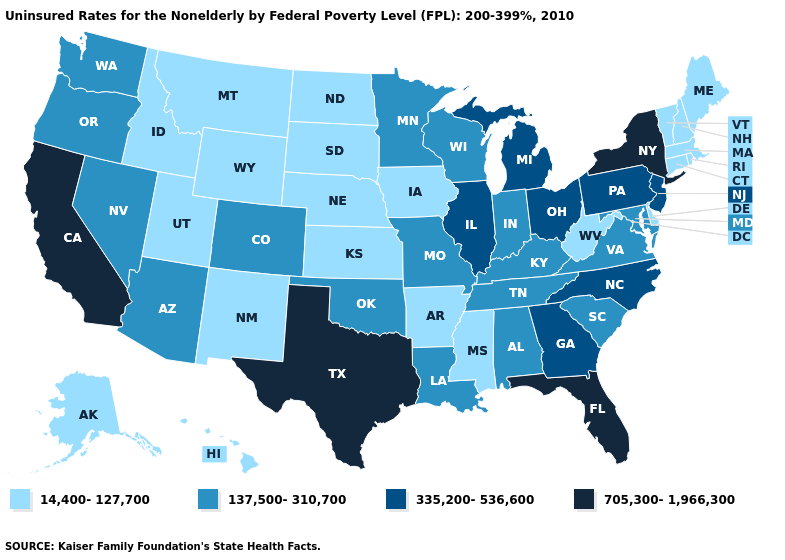How many symbols are there in the legend?
Give a very brief answer. 4. How many symbols are there in the legend?
Write a very short answer. 4. What is the value of Idaho?
Short answer required. 14,400-127,700. What is the value of Ohio?
Be succinct. 335,200-536,600. Name the states that have a value in the range 705,300-1,966,300?
Quick response, please. California, Florida, New York, Texas. What is the value of Oklahoma?
Short answer required. 137,500-310,700. What is the value of Minnesota?
Concise answer only. 137,500-310,700. What is the value of Florida?
Concise answer only. 705,300-1,966,300. Does the map have missing data?
Short answer required. No. What is the value of Illinois?
Give a very brief answer. 335,200-536,600. Among the states that border Minnesota , which have the highest value?
Short answer required. Wisconsin. Which states hav the highest value in the MidWest?
Concise answer only. Illinois, Michigan, Ohio. Does Delaware have a lower value than New Hampshire?
Quick response, please. No. What is the value of Alaska?
Answer briefly. 14,400-127,700. 